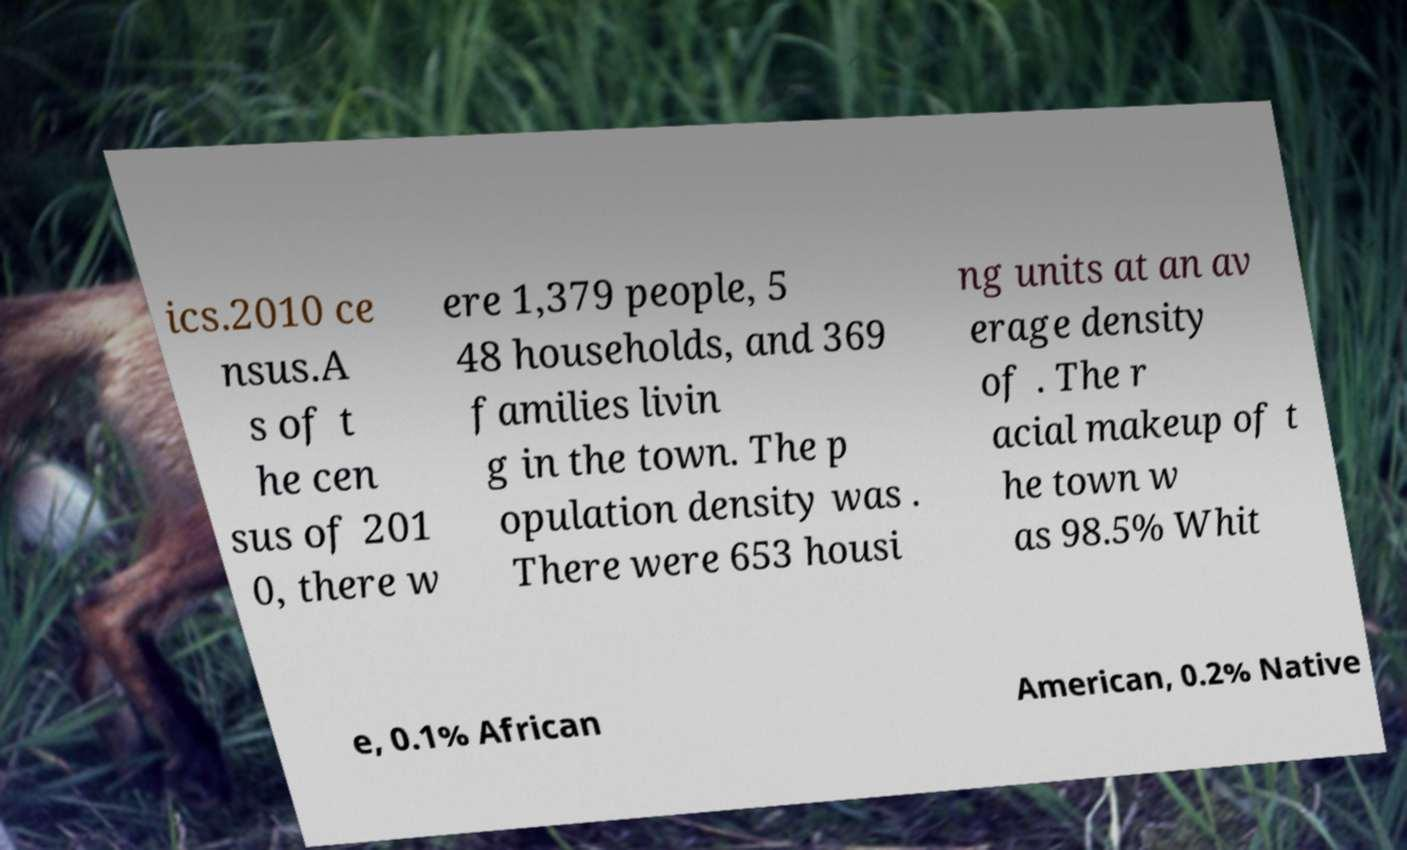What messages or text are displayed in this image? I need them in a readable, typed format. ics.2010 ce nsus.A s of t he cen sus of 201 0, there w ere 1,379 people, 5 48 households, and 369 families livin g in the town. The p opulation density was . There were 653 housi ng units at an av erage density of . The r acial makeup of t he town w as 98.5% Whit e, 0.1% African American, 0.2% Native 